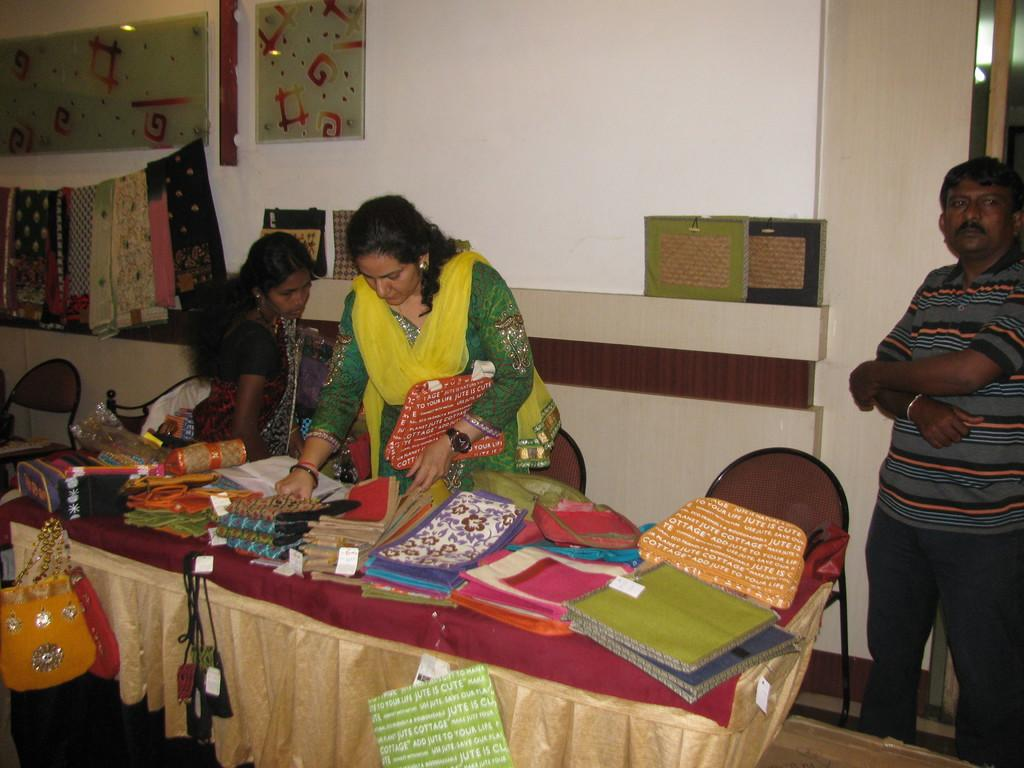How many people are in the image? There are two women and a man in the image. What are the people in the image doing? They are seated at a table. What items can be seen on the table? There are sarees, clothes, and bags on the table. What furniture is present beside the table? There are chairs beside the table. What can be seen in the background of the image? There is a wall in the background of the image. What is hanging on the wall? There are clothes hanging on the wall. What decorative item is present on the wall? There is a frame on the wall. What type of pollution is visible in the image? There is no visible pollution in the image. How many bears are present in the image? There are no bears present in the image. 